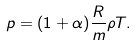<formula> <loc_0><loc_0><loc_500><loc_500>p = ( 1 + \alpha ) \frac { R } { m } \rho T .</formula> 